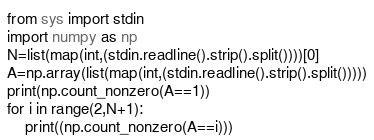Convert code to text. <code><loc_0><loc_0><loc_500><loc_500><_Python_>from sys import stdin
import numpy as np
N=list(map(int,(stdin.readline().strip().split())))[0]
A=np.array(list(map(int,(stdin.readline().strip().split()))))
print(np.count_nonzero(A==1))
for i in range(2,N+1):
    print((np.count_nonzero(A==i)))
</code> 